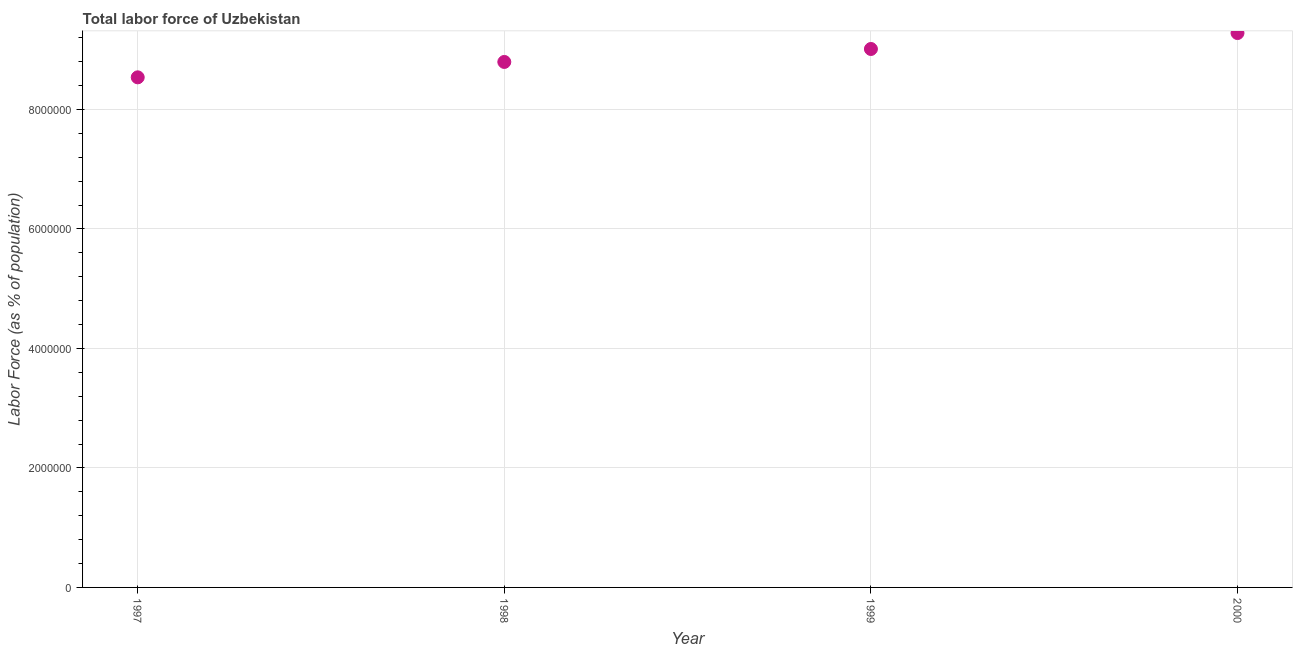What is the total labor force in 1998?
Give a very brief answer. 8.80e+06. Across all years, what is the maximum total labor force?
Give a very brief answer. 9.28e+06. Across all years, what is the minimum total labor force?
Provide a short and direct response. 8.54e+06. In which year was the total labor force minimum?
Offer a terse response. 1997. What is the sum of the total labor force?
Ensure brevity in your answer.  3.56e+07. What is the difference between the total labor force in 1997 and 2000?
Provide a short and direct response. -7.41e+05. What is the average total labor force per year?
Your response must be concise. 8.91e+06. What is the median total labor force?
Your answer should be compact. 8.90e+06. What is the ratio of the total labor force in 1998 to that in 1999?
Make the answer very short. 0.98. Is the total labor force in 1997 less than that in 2000?
Your answer should be very brief. Yes. What is the difference between the highest and the second highest total labor force?
Make the answer very short. 2.67e+05. What is the difference between the highest and the lowest total labor force?
Offer a very short reply. 7.41e+05. In how many years, is the total labor force greater than the average total labor force taken over all years?
Provide a short and direct response. 2. Does the total labor force monotonically increase over the years?
Make the answer very short. Yes. How many years are there in the graph?
Offer a very short reply. 4. What is the difference between two consecutive major ticks on the Y-axis?
Ensure brevity in your answer.  2.00e+06. Does the graph contain grids?
Keep it short and to the point. Yes. What is the title of the graph?
Make the answer very short. Total labor force of Uzbekistan. What is the label or title of the X-axis?
Give a very brief answer. Year. What is the label or title of the Y-axis?
Provide a short and direct response. Labor Force (as % of population). What is the Labor Force (as % of population) in 1997?
Keep it short and to the point. 8.54e+06. What is the Labor Force (as % of population) in 1998?
Your response must be concise. 8.80e+06. What is the Labor Force (as % of population) in 1999?
Give a very brief answer. 9.01e+06. What is the Labor Force (as % of population) in 2000?
Ensure brevity in your answer.  9.28e+06. What is the difference between the Labor Force (as % of population) in 1997 and 1998?
Give a very brief answer. -2.57e+05. What is the difference between the Labor Force (as % of population) in 1997 and 1999?
Your answer should be compact. -4.74e+05. What is the difference between the Labor Force (as % of population) in 1997 and 2000?
Your response must be concise. -7.41e+05. What is the difference between the Labor Force (as % of population) in 1998 and 1999?
Your response must be concise. -2.17e+05. What is the difference between the Labor Force (as % of population) in 1998 and 2000?
Offer a very short reply. -4.84e+05. What is the difference between the Labor Force (as % of population) in 1999 and 2000?
Ensure brevity in your answer.  -2.67e+05. What is the ratio of the Labor Force (as % of population) in 1997 to that in 1998?
Offer a terse response. 0.97. What is the ratio of the Labor Force (as % of population) in 1997 to that in 1999?
Offer a very short reply. 0.95. What is the ratio of the Labor Force (as % of population) in 1998 to that in 2000?
Make the answer very short. 0.95. 